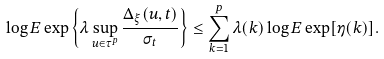Convert formula to latex. <formula><loc_0><loc_0><loc_500><loc_500>\log E \exp \left \{ \lambda \sup _ { u \in \tau ^ { p } } \frac { \Delta _ { \xi } ( u , t ) } { \sigma _ { t } } \right \} \leq \sum _ { k = 1 } ^ { p } \lambda ( k ) \log E \exp [ \eta ( k ) ] .</formula> 